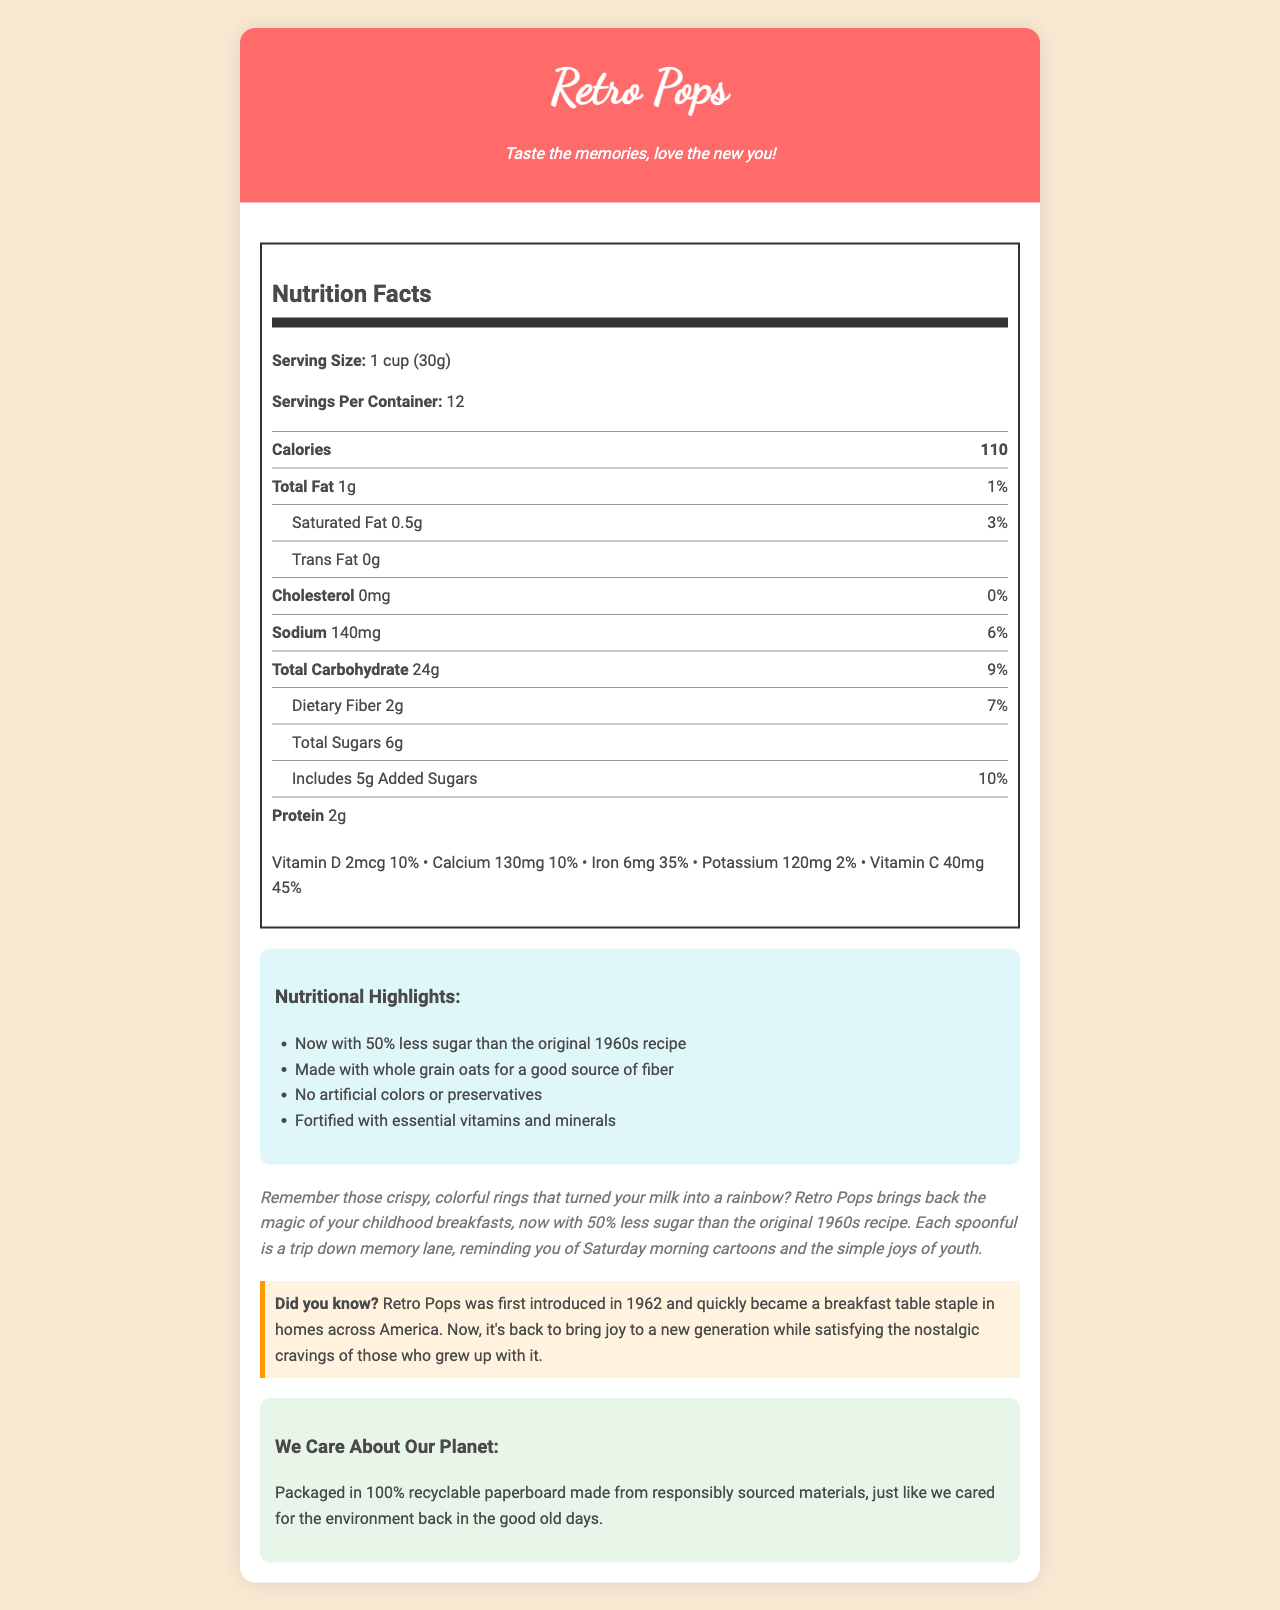what is the serving size of Retro Pops? The serving size is clearly mentioned under the "Nutrition Facts" section as "1 cup (30g)."
Answer: 1 cup (30g) how many servings are in one container? The "Servings Per Container" value is given as 12 in the nutrition information.
Answer: 12 what is the calorie content per serving? The document states the calorie content per serving as 110 in the "Nutrition Facts" panel.
Answer: 110 how much total fat is in each serving? The "Total Fat" content per serving is listed as 1g.
Answer: 1g what percentage of your daily value for iron does one serving of Retro Pops provide? The iron content for each serving provides 35% of the daily value, as stated in the nutrition summary.
Answer: 35% how many grams of dietary fiber are there in one serving? The "Dietary Fiber" content in one serving is listed as 2g in the "Nutrition Facts" section.
Answer: 2g which is NOT one of the ingredients in Retro Pops? A. Whole grain oats B. Corn flour C. Hydrogenated oils D. Sugar The listed ingredients include Whole grain oats, Corn flour, and Sugar, but Hydrogenated oils are not listed.
Answer: C. Hydrogenated oils how much added sugar is in each serving? A. 3g B. 4g C. 5g D. 6g The label specifies that the cereal contains 5g of added sugars per serving.
Answer: C. 5g true or false: Retro Pops contains artificial colors. The nutritional highlights state that the cereal has no artificial colors or preservatives.
Answer: False summarize the main idea of the Retro Pops document. This document includes nutritional facts, nostalgic descriptions, ingredient lists, allergen information, serving suggestions, and sustainability notes, emphasizing both health and sentimental value.
Answer: The document provides nutritional information and nostalgic background for Retro Pops, a revamped 1960s cereal. It highlights reduced sugar content, improved nutritional values, and environmentally friendly packaging. what are the recommended ways to enjoy Retro Pops according to the document? The serving suggestions section lists enjoying the cereal with cold milk, sprinkling it over yogurt, or using it as a topping for ice cream sundaes.
Answer: With cold milk, sprinkled over yogurt, or as a topping for ice cream. what is the purpose of the Vitamin E (mixed tocopherols) in the ingredient list? The ingredient list mentions Vitamin E (mixed tocopherols) as being added to help preserve freshness in the cereal.
Answer: Added to preserve freshness what was the first year Retro Pops were introduced? The historical fact provided in the document states that Retro Pops was first introduced in 1962.
Answer: 1962 who is the target audience for the nostalgic appeal of Retro Pops? The nostalgic description indicates that the product aims to bring back memories for those who had Retro Pops during their childhood in the 1960s.
Answer: Baby boomers who grew up with the original 1960s cereal. does the document mention the exact price of Retro Pops? The document does not provide any pricing information for Retro Pops.
Answer: Not enough information how many calories come from fat per serving? The document provides total fat but does not specify the exact number of calories derived from fat.
Answer: Cannot be determined 